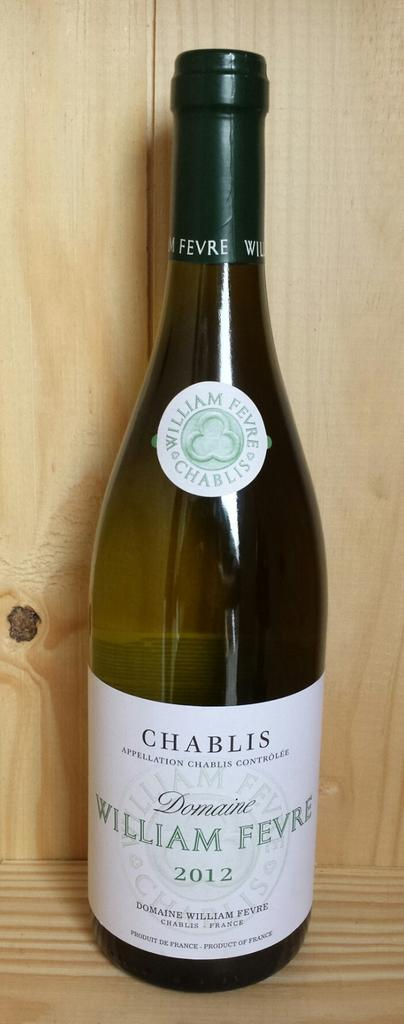<image>
Offer a succinct explanation of the picture presented. A bottle of wine marked William Fevre 2012 sits atop a wooden shelf. 